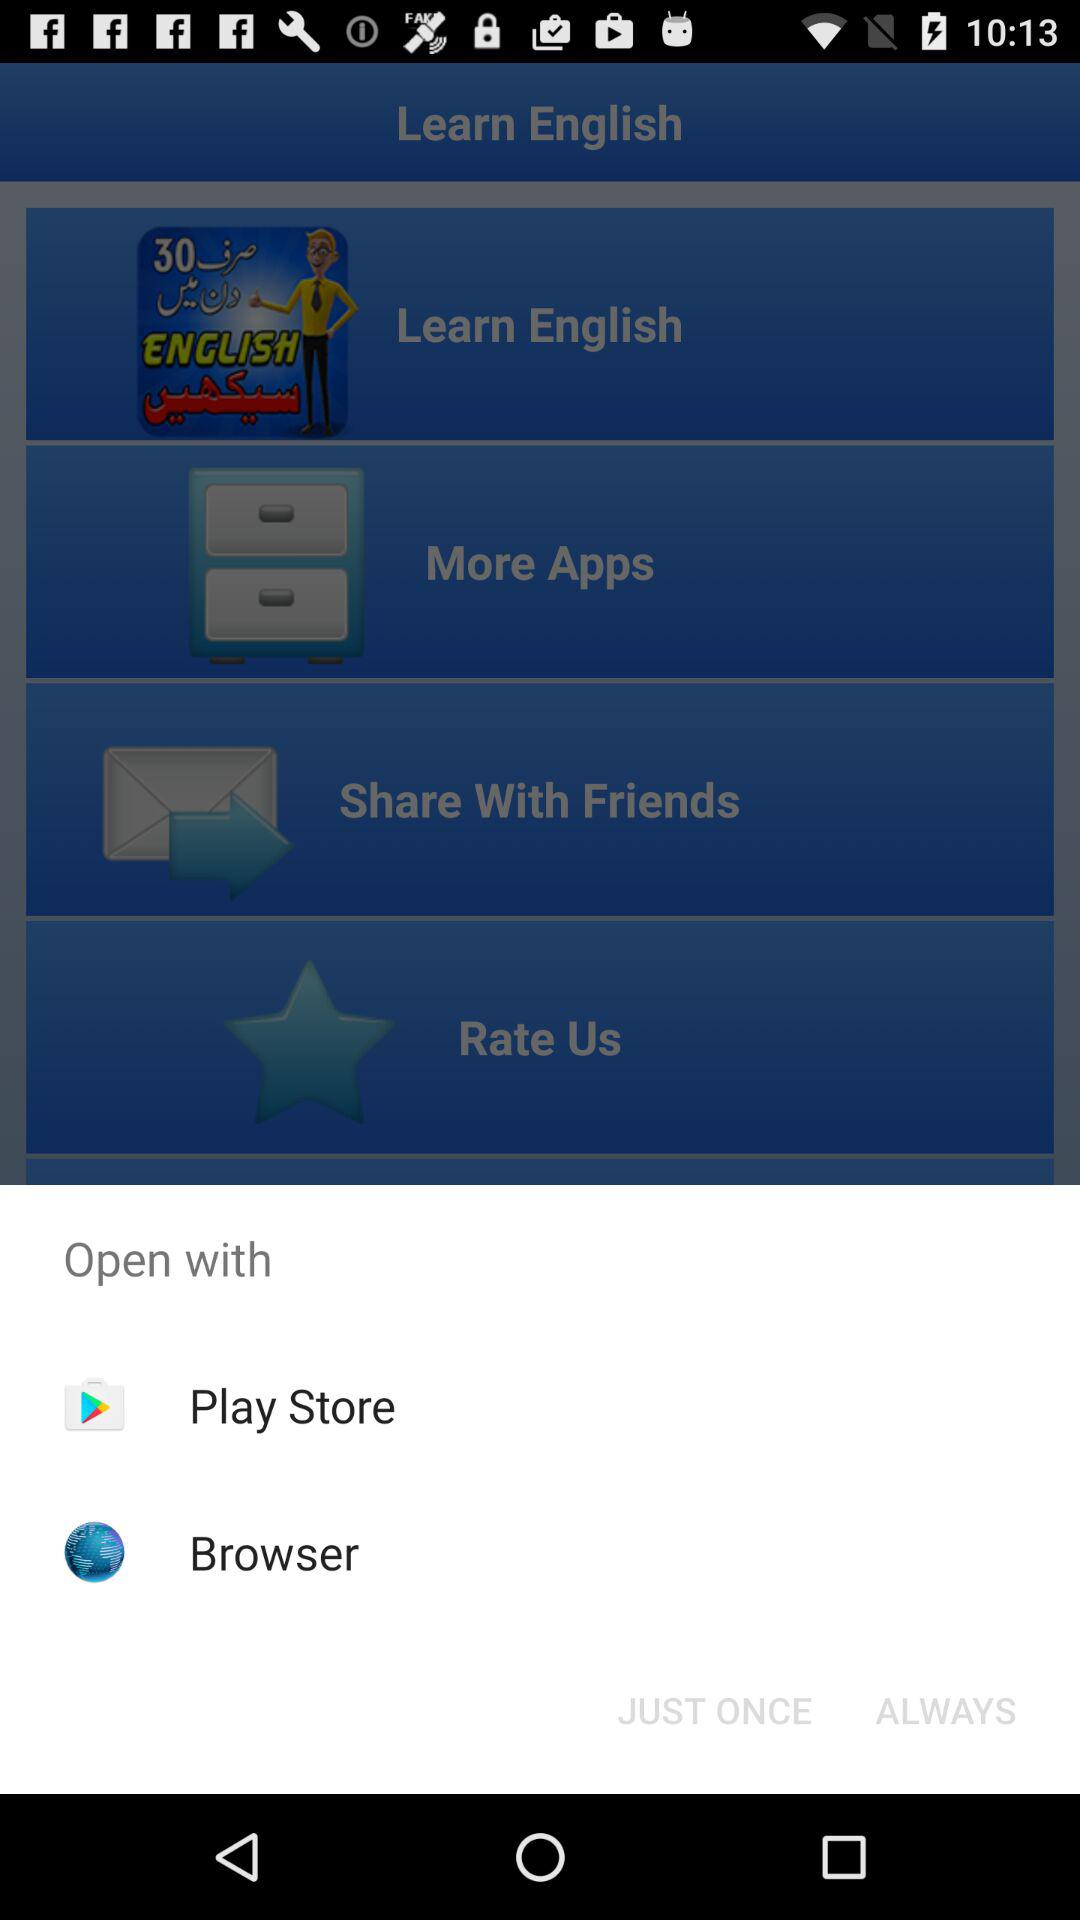What options can I use to open? The options are "Play Store" and "Browser". 